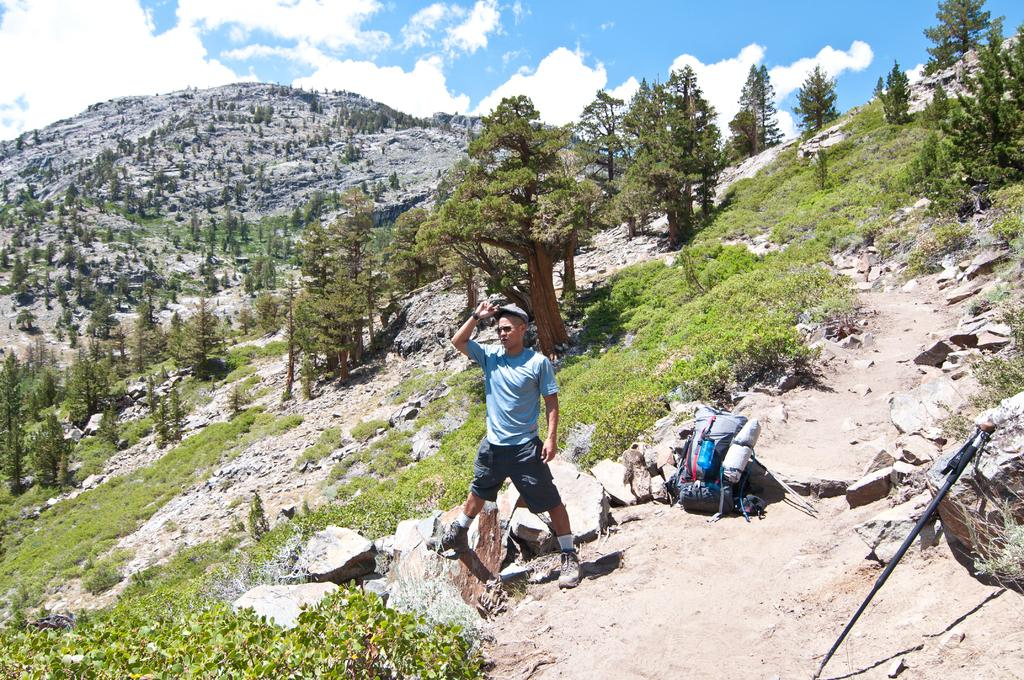Who or what is present in the image? There is a person in the image. What can be seen on the ground in the image? The ground is visible in the image, with grass, plants, and trees. Can you describe any objects in the image? There are objects in the image, but their specific details are not mentioned in the facts. What geographical feature is present in the image? There is a hill in the image. What is visible in the sky in the image? The sky is visible in the image, with clouds. What type of cherry is being crushed by the person in the image? There is no cherry or crushing action present in the image. What type of skin condition is visible on the person in the image? There is no mention of any skin condition or medical issue in the image. 